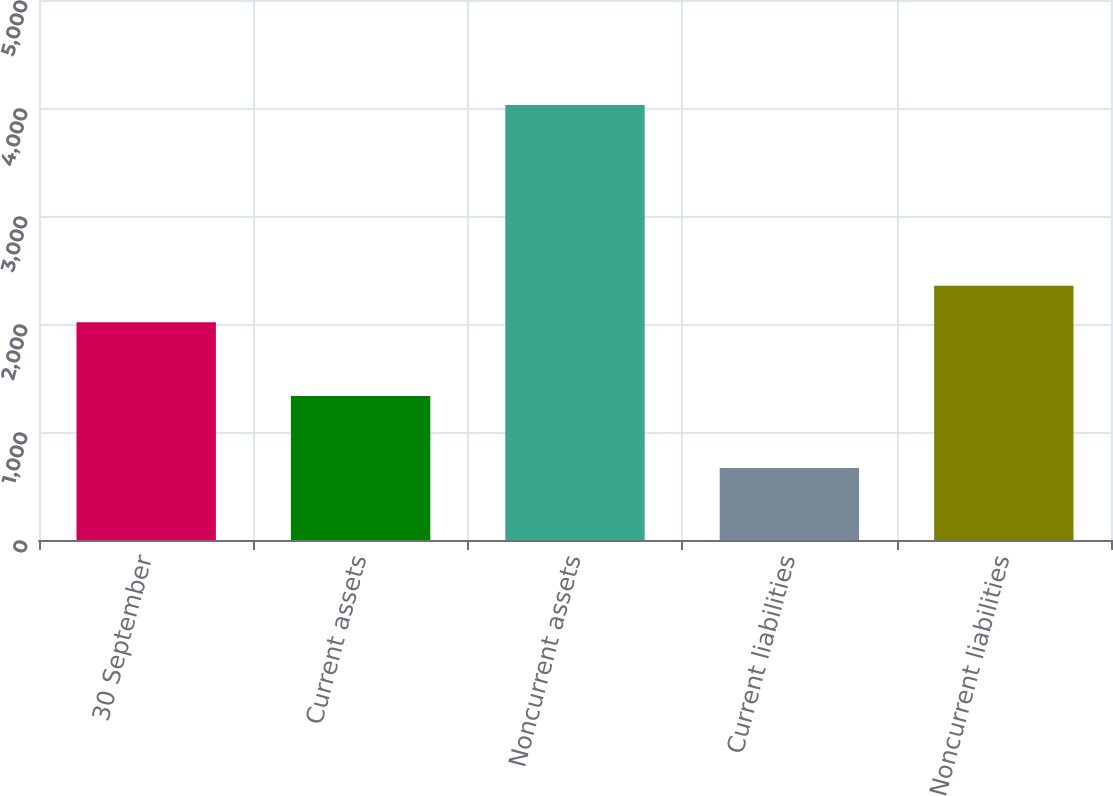Convert chart to OTSL. <chart><loc_0><loc_0><loc_500><loc_500><bar_chart><fcel>30 September<fcel>Current assets<fcel>Noncurrent assets<fcel>Current liabilities<fcel>Noncurrent liabilities<nl><fcel>2017<fcel>1333.2<fcel>4026.9<fcel>666.8<fcel>2353.01<nl></chart> 